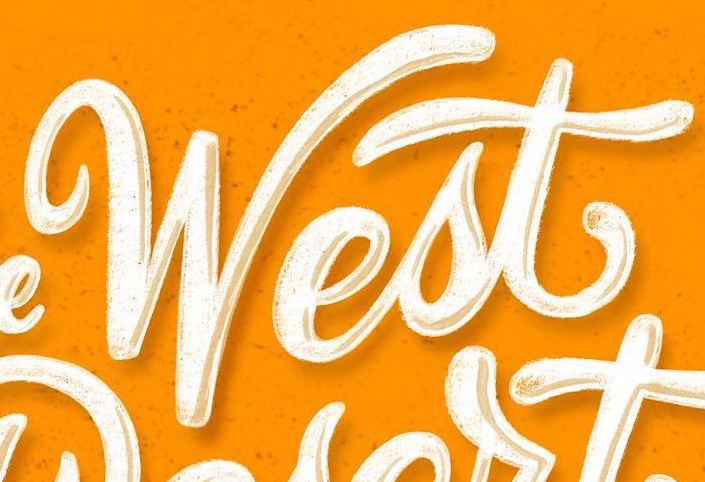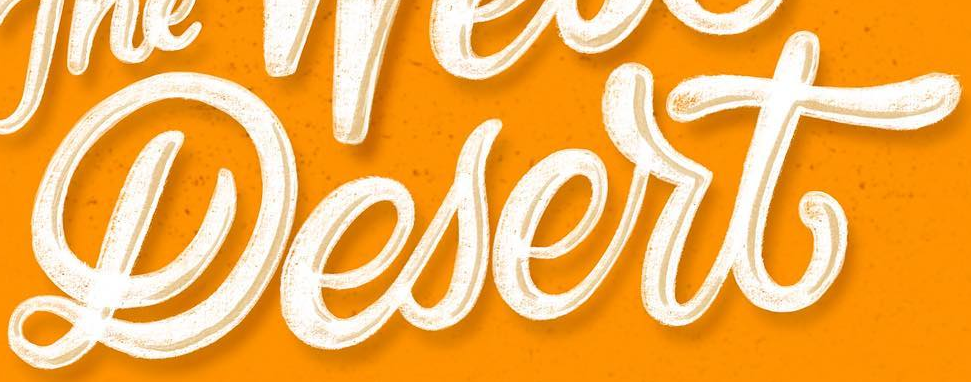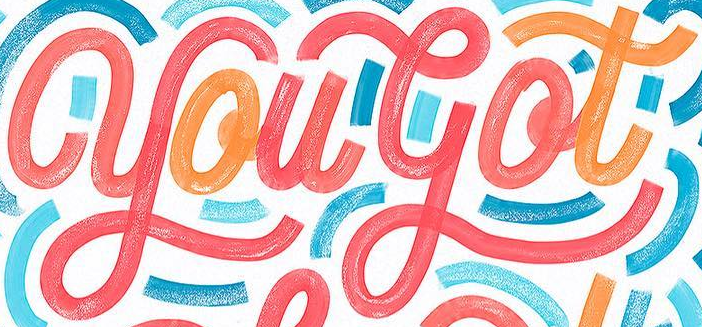Identify the words shown in these images in order, separated by a semicolon. West; Lesert; yougot 